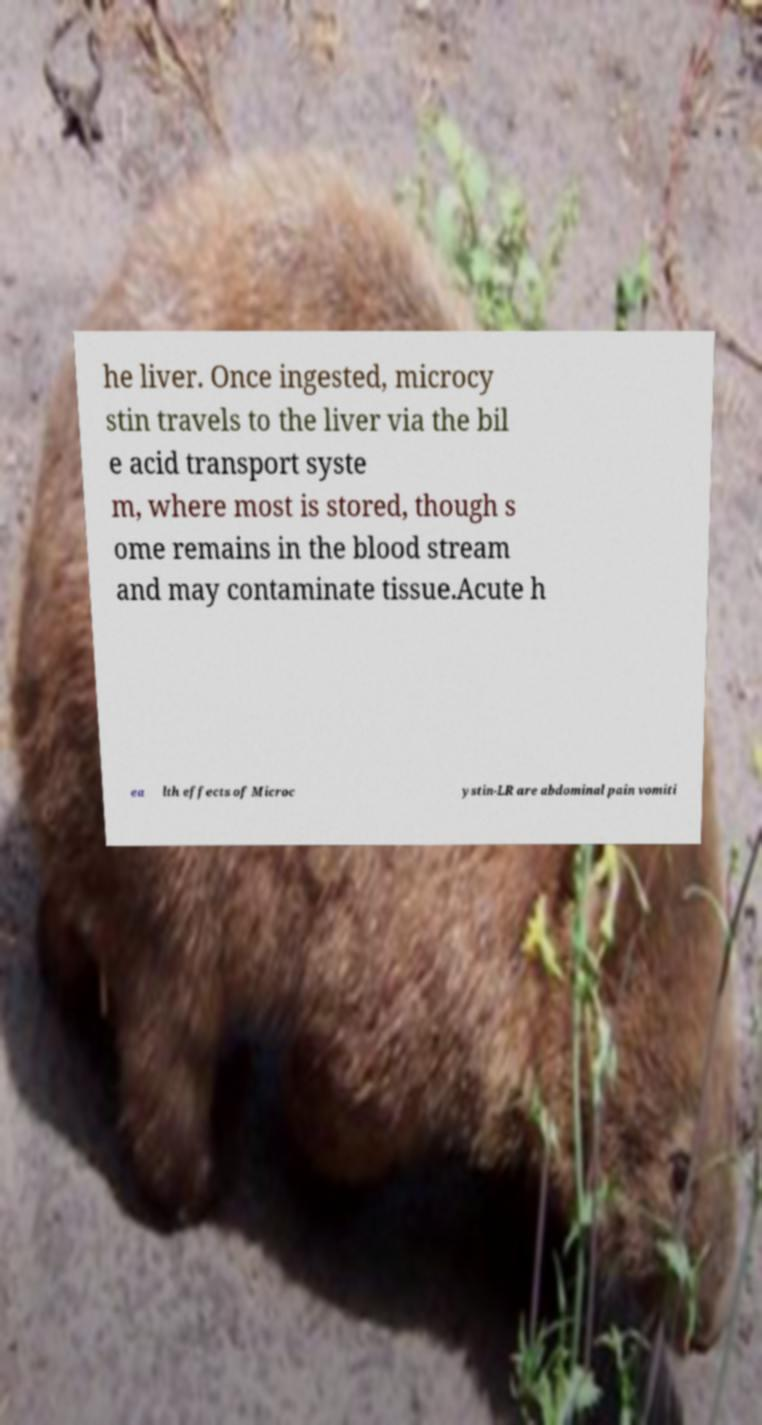Please read and relay the text visible in this image. What does it say? he liver. Once ingested, microcy stin travels to the liver via the bil e acid transport syste m, where most is stored, though s ome remains in the blood stream and may contaminate tissue.Acute h ea lth effects of Microc ystin-LR are abdominal pain vomiti 